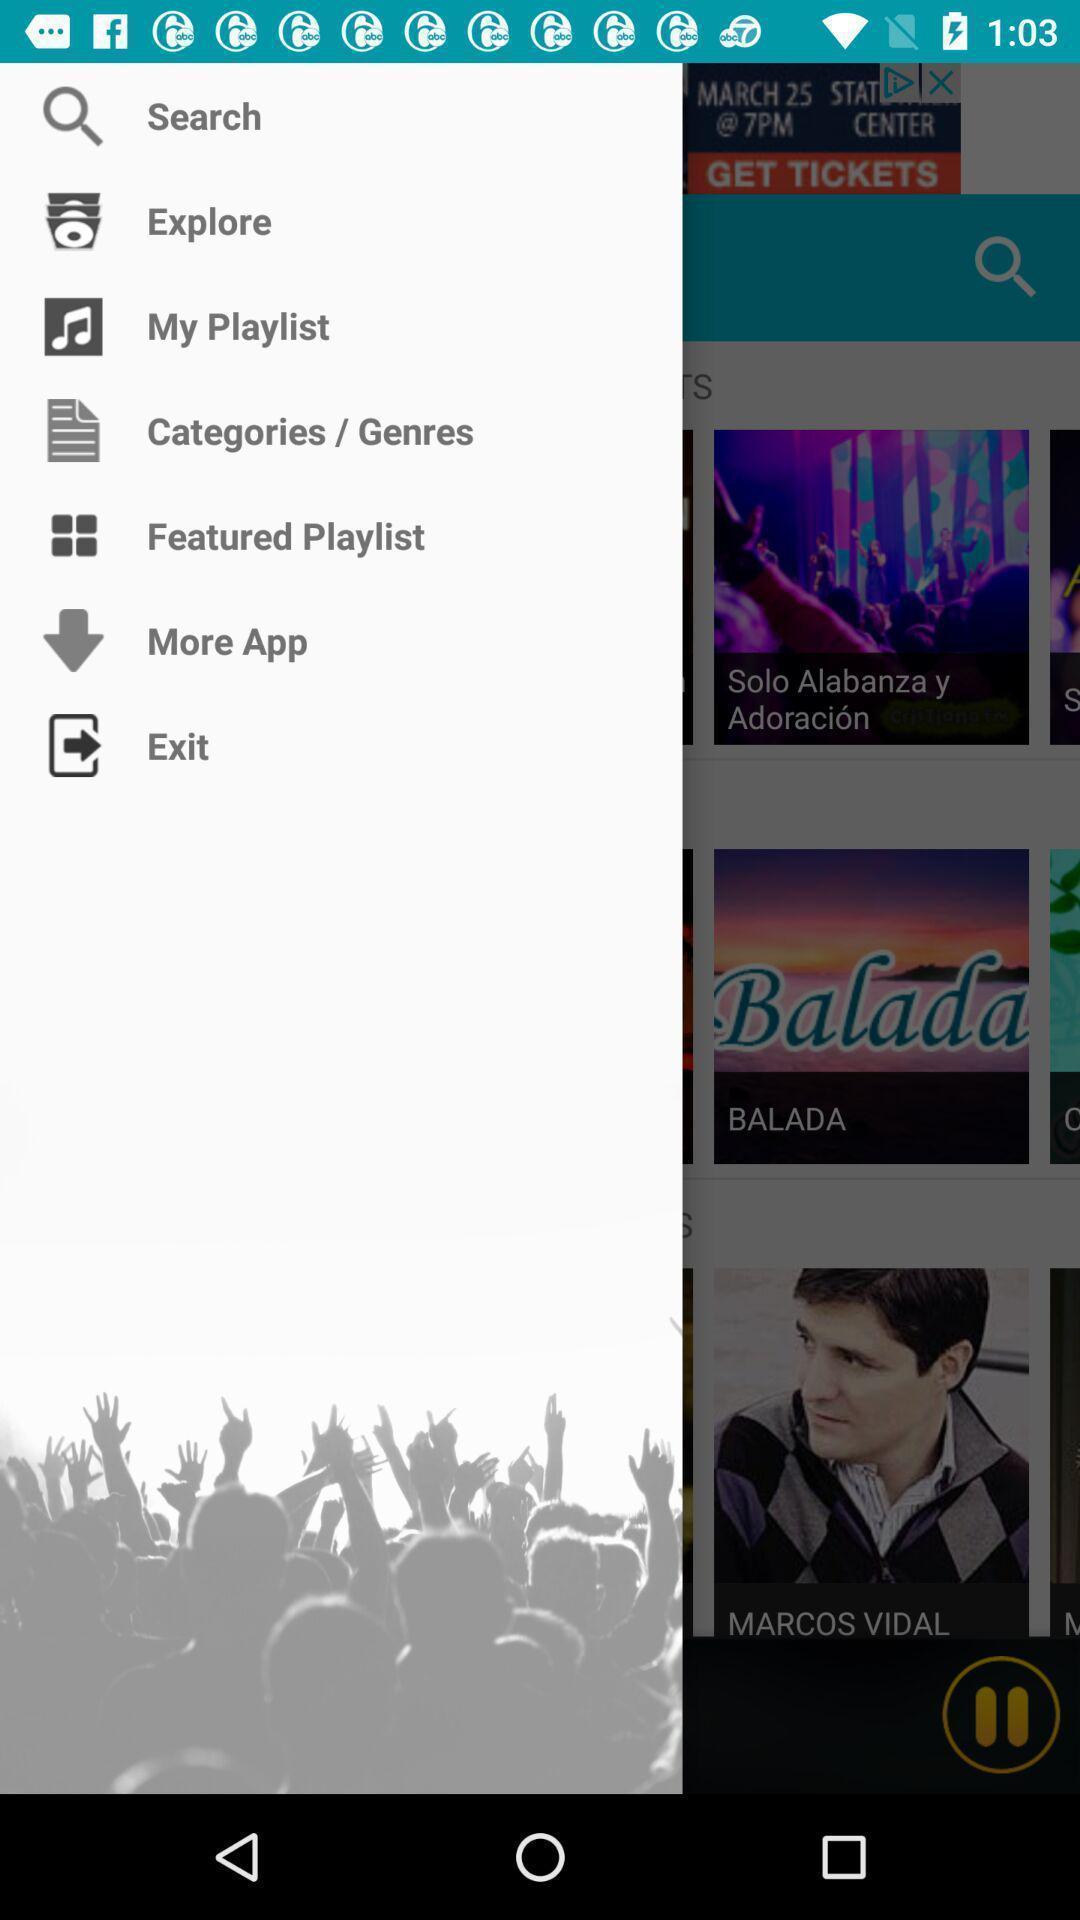Describe the key features of this screenshot. Pop up showing list of options. 